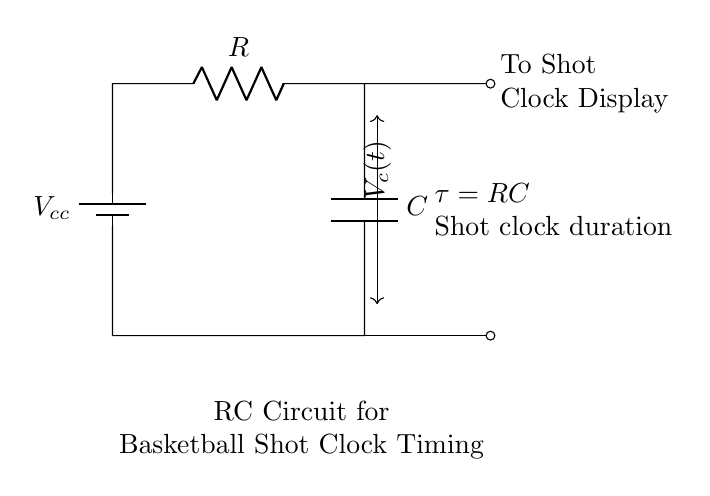What type of circuit is represented here? The circuit is a Resistor-Capacitor (RC) circuit, which consists of a resistor and a capacitor connected in series. The title in the diagram indicates that it is meant for timing purposes in a basketball shot clock.
Answer: RC circuit What components are present in the circuit? The circuit contains two components: a resistor and a capacitor, as indicated by the labels R and C in the diagram.
Answer: Resistor and capacitor What is represented by the voltage notation Vcc? The notation Vcc represents the supply voltage, which is the voltage provided by the battery to the circuit. This is a common notation used to indicate the power source in electronic circuits.
Answer: Supply voltage What does the time constant tau represent? The time constant tau represents the product of the resistance and capacitance (tau = RC). It indicates how quickly the capacitor charges and discharges, affecting the timing of the shot clock.
Answer: RC How does the RC circuit affect the shot clock timing? The RC circuit affects the shot clock timing by determining how long it takes for the voltage across the capacitor to reach a certain level, which would correspond to the timing duration. The time constant directly influences this duration.
Answer: Controls timing duration What does the notation Vc(t) indicate? The notation Vc(t) indicates the voltage across the capacitor as a function of time. This shows how the voltage across the capacitor changes over time during charging and discharging in the timing process.
Answer: Voltage across capacitor What is the purpose of this RC circuit in basketball? The purpose of this RC circuit is to create a timing mechanism for the shot clock, allowing it to accurately measure and display the remaining shot time.
Answer: Timing mechanism for shot clock 